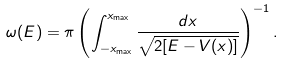Convert formula to latex. <formula><loc_0><loc_0><loc_500><loc_500>\omega ( E ) = \pi \left ( \int _ { - x _ { \max } } ^ { x _ { \max } } \frac { d x } { \sqrt { 2 [ E - V ( x ) ] } } \right ) ^ { - 1 } .</formula> 